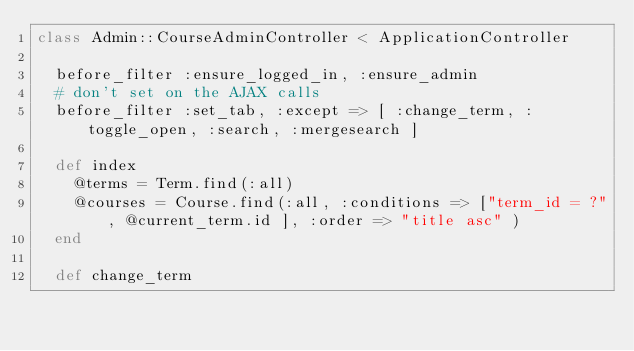<code> <loc_0><loc_0><loc_500><loc_500><_Ruby_>class Admin::CourseAdminController < ApplicationController
  
  before_filter :ensure_logged_in, :ensure_admin
  # don't set on the AJAX calls
  before_filter :set_tab, :except => [ :change_term, :toggle_open, :search, :mergesearch ]
  
  def index
    @terms = Term.find(:all)
    @courses = Course.find(:all, :conditions => ["term_id = ?", @current_term.id ], :order => "title asc" )
  end
  
  def change_term</code> 